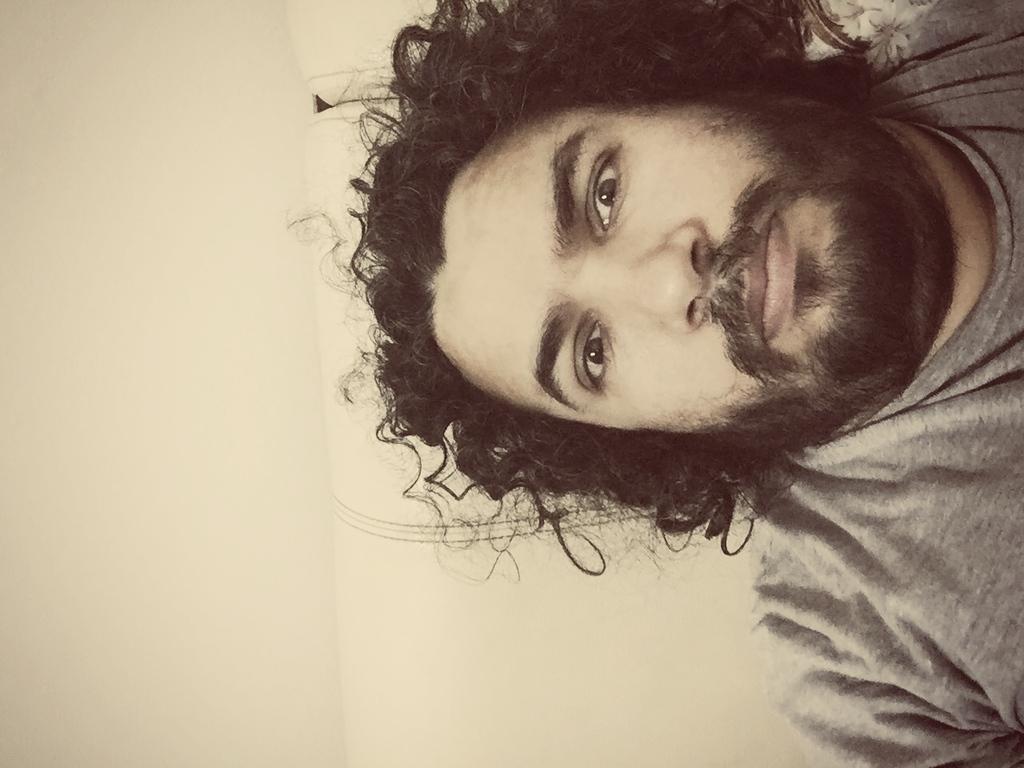Please provide a concise description of this image. In this picture there is a person wearing ash color T-shirt is in the right corner. 